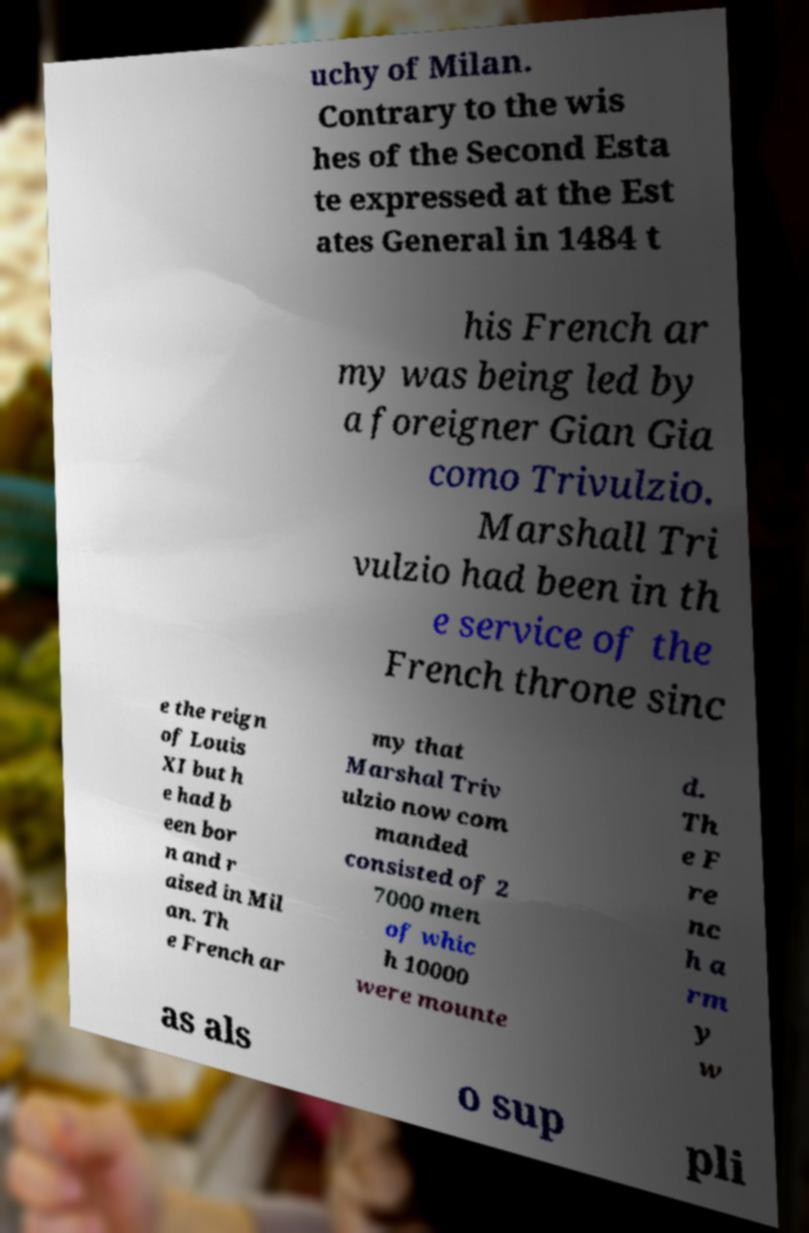Could you assist in decoding the text presented in this image and type it out clearly? uchy of Milan. Contrary to the wis hes of the Second Esta te expressed at the Est ates General in 1484 t his French ar my was being led by a foreigner Gian Gia como Trivulzio. Marshall Tri vulzio had been in th e service of the French throne sinc e the reign of Louis XI but h e had b een bor n and r aised in Mil an. Th e French ar my that Marshal Triv ulzio now com manded consisted of 2 7000 men of whic h 10000 were mounte d. Th e F re nc h a rm y w as als o sup pli 